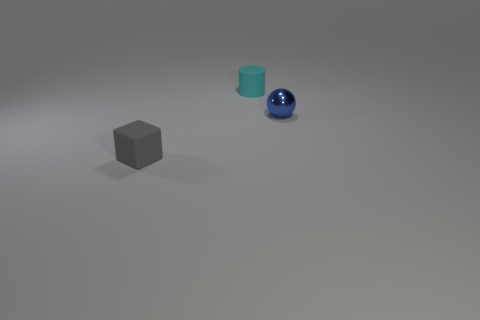Are there any other things that have the same shape as the small metal thing?
Offer a terse response. No. Is there anything else that has the same material as the blue object?
Make the answer very short. No. There is a object in front of the tiny blue sphere; what shape is it?
Your response must be concise. Cube. Do the small thing that is in front of the tiny blue shiny thing and the rubber object that is to the right of the block have the same color?
Give a very brief answer. No. How many objects are either tiny blue metal things or tiny things?
Your answer should be compact. 3. How many other blocks are the same material as the cube?
Provide a short and direct response. 0. Is the number of small blue things less than the number of tiny rubber objects?
Make the answer very short. Yes. Does the tiny thing on the right side of the tiny cyan rubber cylinder have the same material as the small gray block?
Provide a short and direct response. No. What number of cylinders are tiny objects or small gray objects?
Provide a succinct answer. 1. There is a small object that is in front of the tiny cyan matte thing and left of the tiny blue metallic sphere; what is its shape?
Offer a terse response. Cube. 